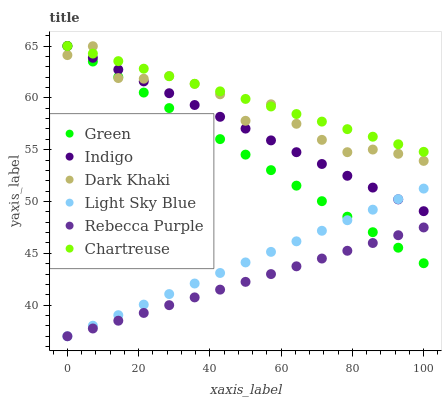Does Rebecca Purple have the minimum area under the curve?
Answer yes or no. Yes. Does Chartreuse have the maximum area under the curve?
Answer yes or no. Yes. Does Dark Khaki have the minimum area under the curve?
Answer yes or no. No. Does Dark Khaki have the maximum area under the curve?
Answer yes or no. No. Is Rebecca Purple the smoothest?
Answer yes or no. Yes. Is Dark Khaki the roughest?
Answer yes or no. Yes. Is Chartreuse the smoothest?
Answer yes or no. No. Is Chartreuse the roughest?
Answer yes or no. No. Does Light Sky Blue have the lowest value?
Answer yes or no. Yes. Does Dark Khaki have the lowest value?
Answer yes or no. No. Does Green have the highest value?
Answer yes or no. Yes. Does Dark Khaki have the highest value?
Answer yes or no. No. Is Rebecca Purple less than Chartreuse?
Answer yes or no. Yes. Is Dark Khaki greater than Light Sky Blue?
Answer yes or no. Yes. Does Light Sky Blue intersect Green?
Answer yes or no. Yes. Is Light Sky Blue less than Green?
Answer yes or no. No. Is Light Sky Blue greater than Green?
Answer yes or no. No. Does Rebecca Purple intersect Chartreuse?
Answer yes or no. No. 